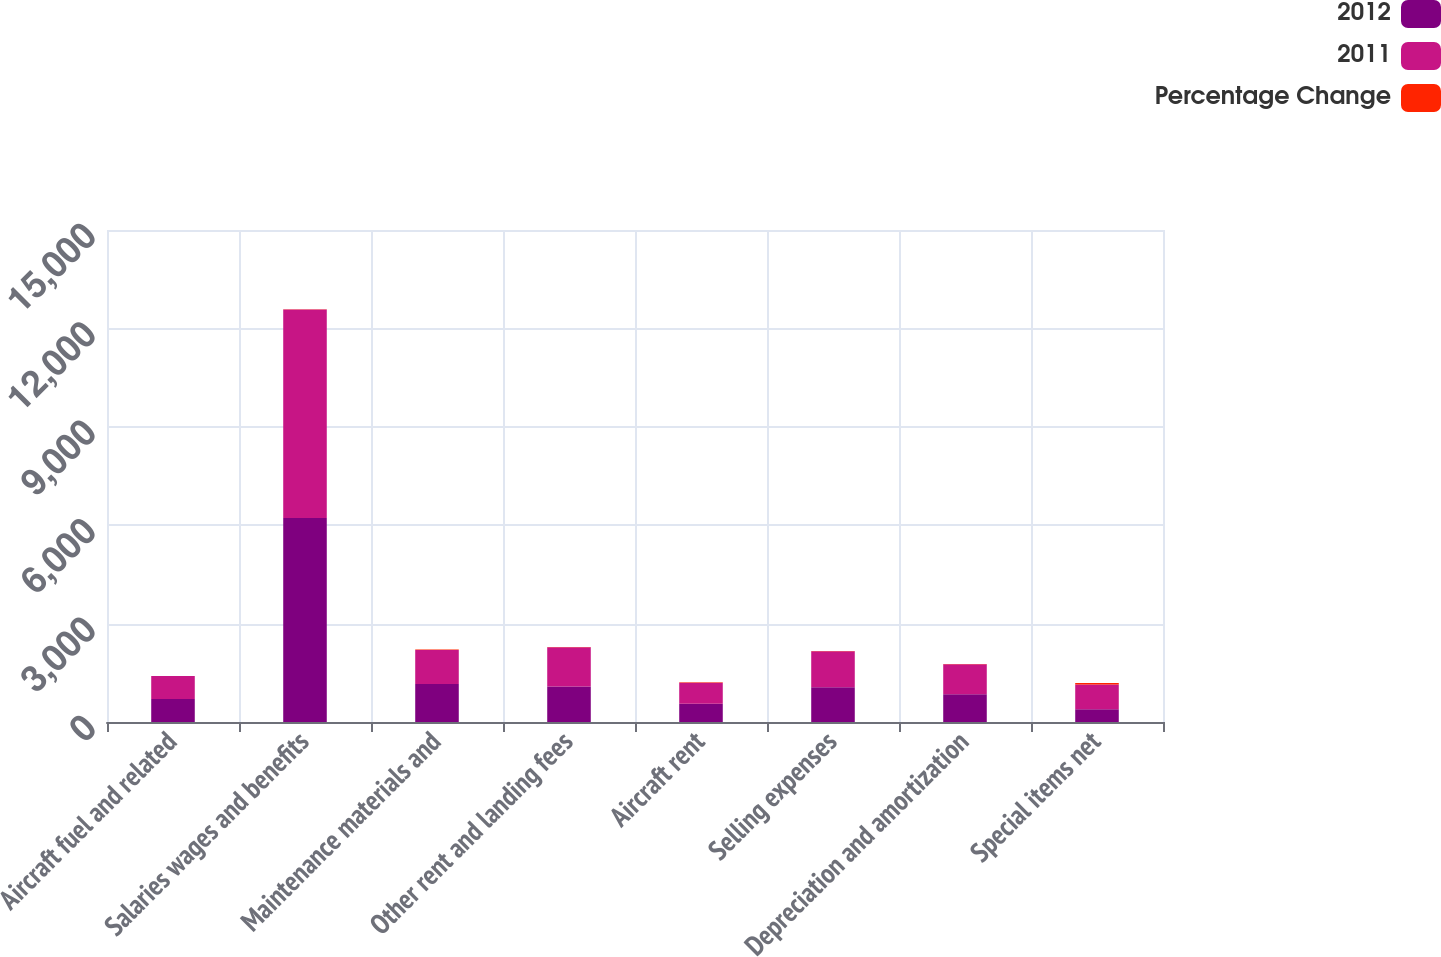<chart> <loc_0><loc_0><loc_500><loc_500><stacked_bar_chart><ecel><fcel>Aircraft fuel and related<fcel>Salaries wages and benefits<fcel>Maintenance materials and<fcel>Other rent and landing fees<fcel>Aircraft rent<fcel>Selling expenses<fcel>Depreciation and amortization<fcel>Special items net<nl><fcel>2012<fcel>700.5<fcel>6217<fcel>1158<fcel>1083<fcel>553<fcel>1058<fcel>845<fcel>386<nl><fcel>2011<fcel>700.5<fcel>6361<fcel>1039<fcel>1194<fcel>645<fcel>1102<fcel>915<fcel>756<nl><fcel>Percentage Change<fcel>4.7<fcel>2.3<fcel>11.5<fcel>9.3<fcel>14.3<fcel>4<fcel>7.7<fcel>48.9<nl></chart> 